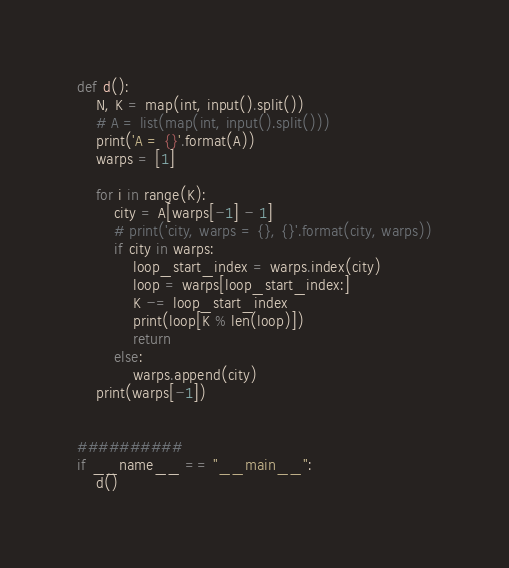Convert code to text. <code><loc_0><loc_0><loc_500><loc_500><_Python_>def d():
    N, K = map(int, input().split())
    # A = list(map(int, input().split()))
    print('A = {}'.format(A))
    warps = [1]

    for i in range(K):
        city = A[warps[-1] - 1]
        # print('city, warps = {}, {}'.format(city, warps))
        if city in warps:
            loop_start_index = warps.index(city)
            loop = warps[loop_start_index:]
            K -= loop_start_index
            print(loop[K % len(loop)])
            return
        else:
            warps.append(city)
    print(warps[-1])


##########
if __name__ == "__main__":
    d()
</code> 